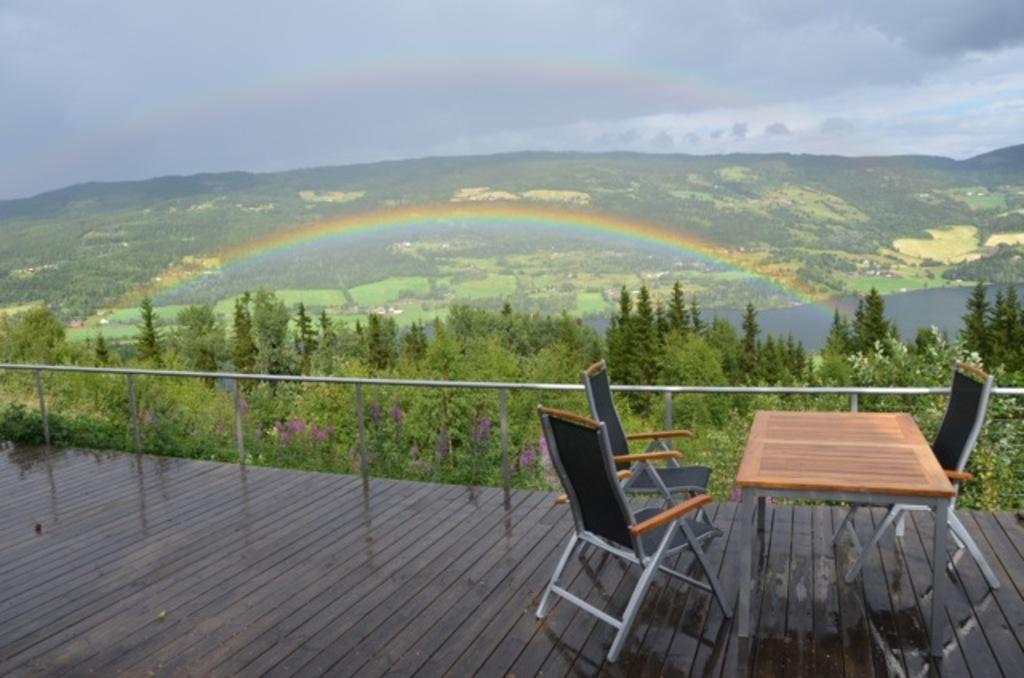What type of furniture can be seen in the image? There are chairs and a table in the image. What is the surface that the chairs and table are placed on? The chairs and table are on a wooden surface. What architectural feature is present in the image? There is rod railing in the image. What can be seen in the background of the image? Trees, hills, water, a rainbow, and a cloudy sky are visible in the background of the image. How many nails are used to hold the table together in the image? There is no information about nails or the construction of the table in the image. 